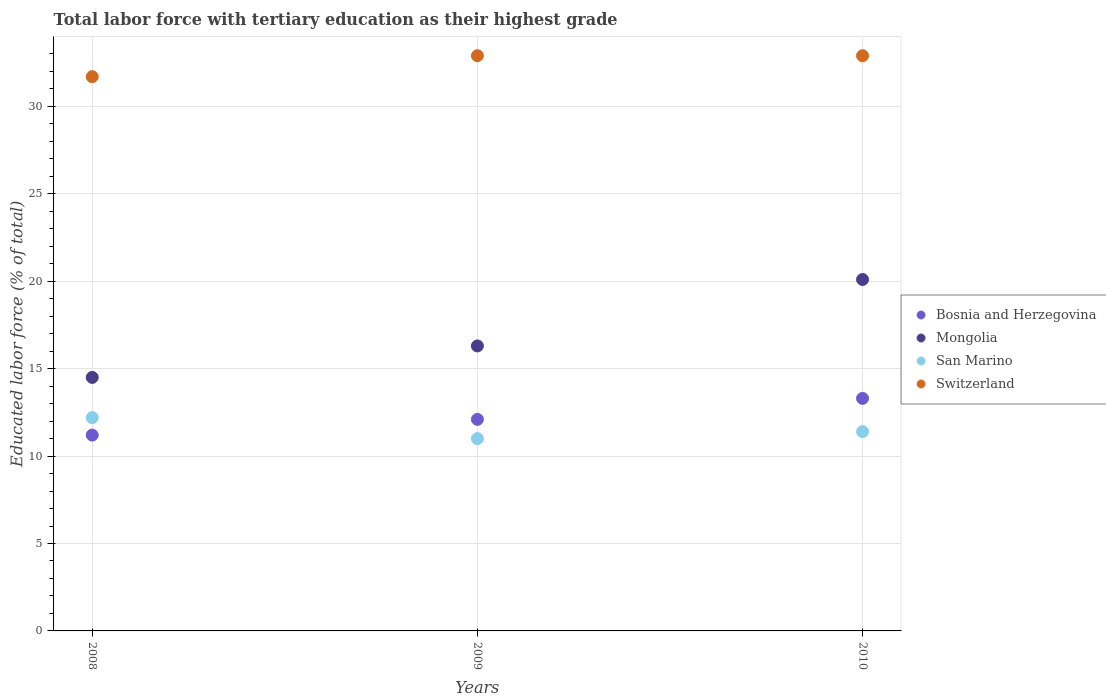How many different coloured dotlines are there?
Give a very brief answer. 4. What is the percentage of male labor force with tertiary education in Mongolia in 2009?
Keep it short and to the point. 16.3. Across all years, what is the maximum percentage of male labor force with tertiary education in Mongolia?
Your answer should be compact. 20.1. In which year was the percentage of male labor force with tertiary education in Mongolia maximum?
Offer a terse response. 2010. What is the total percentage of male labor force with tertiary education in Bosnia and Herzegovina in the graph?
Give a very brief answer. 36.6. What is the difference between the percentage of male labor force with tertiary education in Mongolia in 2008 and that in 2009?
Your response must be concise. -1.8. What is the difference between the percentage of male labor force with tertiary education in Bosnia and Herzegovina in 2010 and the percentage of male labor force with tertiary education in Mongolia in 2008?
Make the answer very short. -1.2. What is the average percentage of male labor force with tertiary education in Mongolia per year?
Make the answer very short. 16.97. In the year 2010, what is the difference between the percentage of male labor force with tertiary education in San Marino and percentage of male labor force with tertiary education in Mongolia?
Ensure brevity in your answer.  -8.7. In how many years, is the percentage of male labor force with tertiary education in Bosnia and Herzegovina greater than 2 %?
Your response must be concise. 3. What is the ratio of the percentage of male labor force with tertiary education in Mongolia in 2008 to that in 2009?
Make the answer very short. 0.89. Is the percentage of male labor force with tertiary education in Switzerland in 2008 less than that in 2009?
Provide a short and direct response. Yes. What is the difference between the highest and the lowest percentage of male labor force with tertiary education in Switzerland?
Offer a very short reply. 1.2. Is the sum of the percentage of male labor force with tertiary education in Switzerland in 2008 and 2010 greater than the maximum percentage of male labor force with tertiary education in San Marino across all years?
Offer a terse response. Yes. Is it the case that in every year, the sum of the percentage of male labor force with tertiary education in San Marino and percentage of male labor force with tertiary education in Mongolia  is greater than the percentage of male labor force with tertiary education in Bosnia and Herzegovina?
Offer a terse response. Yes. Is the percentage of male labor force with tertiary education in Bosnia and Herzegovina strictly less than the percentage of male labor force with tertiary education in Switzerland over the years?
Provide a short and direct response. Yes. How many dotlines are there?
Your answer should be very brief. 4. Does the graph contain any zero values?
Provide a short and direct response. No. Does the graph contain grids?
Make the answer very short. Yes. Where does the legend appear in the graph?
Provide a short and direct response. Center right. How many legend labels are there?
Provide a succinct answer. 4. What is the title of the graph?
Your response must be concise. Total labor force with tertiary education as their highest grade. What is the label or title of the Y-axis?
Offer a terse response. Educated labor force (% of total). What is the Educated labor force (% of total) in Bosnia and Herzegovina in 2008?
Keep it short and to the point. 11.2. What is the Educated labor force (% of total) in Mongolia in 2008?
Provide a succinct answer. 14.5. What is the Educated labor force (% of total) in San Marino in 2008?
Your response must be concise. 12.2. What is the Educated labor force (% of total) in Switzerland in 2008?
Keep it short and to the point. 31.7. What is the Educated labor force (% of total) in Bosnia and Herzegovina in 2009?
Keep it short and to the point. 12.1. What is the Educated labor force (% of total) of Mongolia in 2009?
Make the answer very short. 16.3. What is the Educated labor force (% of total) of Switzerland in 2009?
Your answer should be compact. 32.9. What is the Educated labor force (% of total) of Bosnia and Herzegovina in 2010?
Keep it short and to the point. 13.3. What is the Educated labor force (% of total) in Mongolia in 2010?
Ensure brevity in your answer.  20.1. What is the Educated labor force (% of total) in San Marino in 2010?
Ensure brevity in your answer.  11.4. What is the Educated labor force (% of total) in Switzerland in 2010?
Ensure brevity in your answer.  32.9. Across all years, what is the maximum Educated labor force (% of total) of Bosnia and Herzegovina?
Your response must be concise. 13.3. Across all years, what is the maximum Educated labor force (% of total) of Mongolia?
Keep it short and to the point. 20.1. Across all years, what is the maximum Educated labor force (% of total) of San Marino?
Give a very brief answer. 12.2. Across all years, what is the maximum Educated labor force (% of total) in Switzerland?
Your response must be concise. 32.9. Across all years, what is the minimum Educated labor force (% of total) in Bosnia and Herzegovina?
Offer a very short reply. 11.2. Across all years, what is the minimum Educated labor force (% of total) of San Marino?
Your response must be concise. 11. Across all years, what is the minimum Educated labor force (% of total) of Switzerland?
Provide a short and direct response. 31.7. What is the total Educated labor force (% of total) of Bosnia and Herzegovina in the graph?
Your answer should be very brief. 36.6. What is the total Educated labor force (% of total) of Mongolia in the graph?
Offer a very short reply. 50.9. What is the total Educated labor force (% of total) in San Marino in the graph?
Your response must be concise. 34.6. What is the total Educated labor force (% of total) in Switzerland in the graph?
Provide a short and direct response. 97.5. What is the difference between the Educated labor force (% of total) in Bosnia and Herzegovina in 2008 and that in 2010?
Your response must be concise. -2.1. What is the difference between the Educated labor force (% of total) in Mongolia in 2008 and that in 2010?
Your answer should be compact. -5.6. What is the difference between the Educated labor force (% of total) in San Marino in 2009 and that in 2010?
Give a very brief answer. -0.4. What is the difference between the Educated labor force (% of total) of Bosnia and Herzegovina in 2008 and the Educated labor force (% of total) of Mongolia in 2009?
Keep it short and to the point. -5.1. What is the difference between the Educated labor force (% of total) of Bosnia and Herzegovina in 2008 and the Educated labor force (% of total) of San Marino in 2009?
Provide a succinct answer. 0.2. What is the difference between the Educated labor force (% of total) in Bosnia and Herzegovina in 2008 and the Educated labor force (% of total) in Switzerland in 2009?
Give a very brief answer. -21.7. What is the difference between the Educated labor force (% of total) of Mongolia in 2008 and the Educated labor force (% of total) of Switzerland in 2009?
Your answer should be compact. -18.4. What is the difference between the Educated labor force (% of total) in San Marino in 2008 and the Educated labor force (% of total) in Switzerland in 2009?
Offer a very short reply. -20.7. What is the difference between the Educated labor force (% of total) of Bosnia and Herzegovina in 2008 and the Educated labor force (% of total) of Mongolia in 2010?
Provide a succinct answer. -8.9. What is the difference between the Educated labor force (% of total) of Bosnia and Herzegovina in 2008 and the Educated labor force (% of total) of San Marino in 2010?
Ensure brevity in your answer.  -0.2. What is the difference between the Educated labor force (% of total) in Bosnia and Herzegovina in 2008 and the Educated labor force (% of total) in Switzerland in 2010?
Your answer should be very brief. -21.7. What is the difference between the Educated labor force (% of total) in Mongolia in 2008 and the Educated labor force (% of total) in Switzerland in 2010?
Your answer should be compact. -18.4. What is the difference between the Educated labor force (% of total) of San Marino in 2008 and the Educated labor force (% of total) of Switzerland in 2010?
Provide a succinct answer. -20.7. What is the difference between the Educated labor force (% of total) of Bosnia and Herzegovina in 2009 and the Educated labor force (% of total) of San Marino in 2010?
Provide a short and direct response. 0.7. What is the difference between the Educated labor force (% of total) of Bosnia and Herzegovina in 2009 and the Educated labor force (% of total) of Switzerland in 2010?
Your answer should be compact. -20.8. What is the difference between the Educated labor force (% of total) in Mongolia in 2009 and the Educated labor force (% of total) in Switzerland in 2010?
Offer a very short reply. -16.6. What is the difference between the Educated labor force (% of total) of San Marino in 2009 and the Educated labor force (% of total) of Switzerland in 2010?
Your answer should be very brief. -21.9. What is the average Educated labor force (% of total) of Bosnia and Herzegovina per year?
Provide a succinct answer. 12.2. What is the average Educated labor force (% of total) of Mongolia per year?
Offer a terse response. 16.97. What is the average Educated labor force (% of total) in San Marino per year?
Make the answer very short. 11.53. What is the average Educated labor force (% of total) of Switzerland per year?
Make the answer very short. 32.5. In the year 2008, what is the difference between the Educated labor force (% of total) of Bosnia and Herzegovina and Educated labor force (% of total) of Switzerland?
Offer a terse response. -20.5. In the year 2008, what is the difference between the Educated labor force (% of total) in Mongolia and Educated labor force (% of total) in San Marino?
Give a very brief answer. 2.3. In the year 2008, what is the difference between the Educated labor force (% of total) in Mongolia and Educated labor force (% of total) in Switzerland?
Give a very brief answer. -17.2. In the year 2008, what is the difference between the Educated labor force (% of total) of San Marino and Educated labor force (% of total) of Switzerland?
Provide a succinct answer. -19.5. In the year 2009, what is the difference between the Educated labor force (% of total) in Bosnia and Herzegovina and Educated labor force (% of total) in Switzerland?
Provide a short and direct response. -20.8. In the year 2009, what is the difference between the Educated labor force (% of total) in Mongolia and Educated labor force (% of total) in San Marino?
Make the answer very short. 5.3. In the year 2009, what is the difference between the Educated labor force (% of total) of Mongolia and Educated labor force (% of total) of Switzerland?
Give a very brief answer. -16.6. In the year 2009, what is the difference between the Educated labor force (% of total) in San Marino and Educated labor force (% of total) in Switzerland?
Keep it short and to the point. -21.9. In the year 2010, what is the difference between the Educated labor force (% of total) in Bosnia and Herzegovina and Educated labor force (% of total) in San Marino?
Make the answer very short. 1.9. In the year 2010, what is the difference between the Educated labor force (% of total) in Bosnia and Herzegovina and Educated labor force (% of total) in Switzerland?
Your response must be concise. -19.6. In the year 2010, what is the difference between the Educated labor force (% of total) of Mongolia and Educated labor force (% of total) of San Marino?
Keep it short and to the point. 8.7. In the year 2010, what is the difference between the Educated labor force (% of total) in San Marino and Educated labor force (% of total) in Switzerland?
Make the answer very short. -21.5. What is the ratio of the Educated labor force (% of total) of Bosnia and Herzegovina in 2008 to that in 2009?
Provide a succinct answer. 0.93. What is the ratio of the Educated labor force (% of total) in Mongolia in 2008 to that in 2009?
Keep it short and to the point. 0.89. What is the ratio of the Educated labor force (% of total) in San Marino in 2008 to that in 2009?
Make the answer very short. 1.11. What is the ratio of the Educated labor force (% of total) of Switzerland in 2008 to that in 2009?
Make the answer very short. 0.96. What is the ratio of the Educated labor force (% of total) in Bosnia and Herzegovina in 2008 to that in 2010?
Give a very brief answer. 0.84. What is the ratio of the Educated labor force (% of total) of Mongolia in 2008 to that in 2010?
Offer a very short reply. 0.72. What is the ratio of the Educated labor force (% of total) of San Marino in 2008 to that in 2010?
Ensure brevity in your answer.  1.07. What is the ratio of the Educated labor force (% of total) of Switzerland in 2008 to that in 2010?
Your response must be concise. 0.96. What is the ratio of the Educated labor force (% of total) of Bosnia and Herzegovina in 2009 to that in 2010?
Your response must be concise. 0.91. What is the ratio of the Educated labor force (% of total) of Mongolia in 2009 to that in 2010?
Provide a short and direct response. 0.81. What is the ratio of the Educated labor force (% of total) in San Marino in 2009 to that in 2010?
Offer a very short reply. 0.96. What is the ratio of the Educated labor force (% of total) of Switzerland in 2009 to that in 2010?
Provide a short and direct response. 1. What is the difference between the highest and the second highest Educated labor force (% of total) in San Marino?
Offer a terse response. 0.8. 